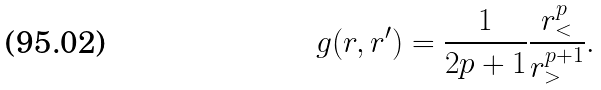<formula> <loc_0><loc_0><loc_500><loc_500>g ( r , r ^ { \prime } ) = \frac { 1 } { 2 p + 1 } \frac { r _ { < } ^ { p } } { r _ { > } ^ { p + 1 } } .</formula> 